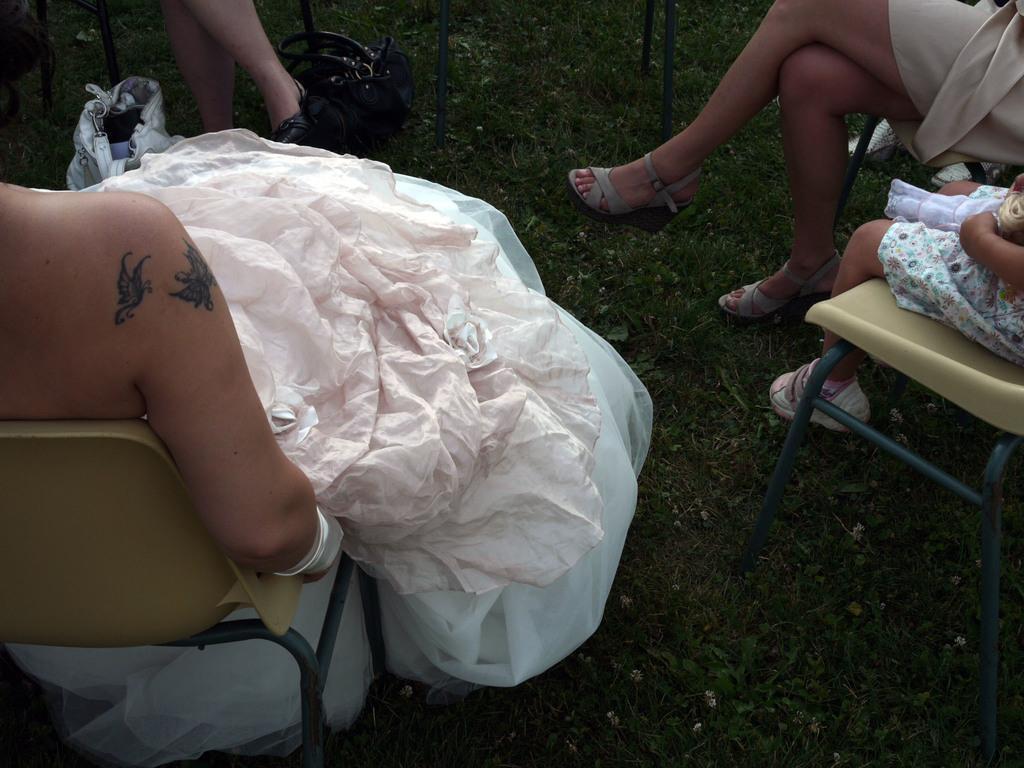In one or two sentences, can you explain what this image depicts? This image is taken outdoors. At the bottom of the image there is a ground with grass on it. On the left side of the image a woman is sitting on the chair and she has worn a white frock. On the right side of the image a woman and a kid are sitting on the chairs. At the top of the image a person is sitting on the chair. 